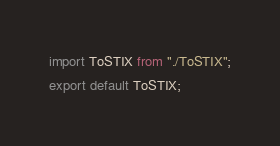<code> <loc_0><loc_0><loc_500><loc_500><_JavaScript_>import ToSTIX from "./ToSTIX";
export default ToSTIX;
</code> 